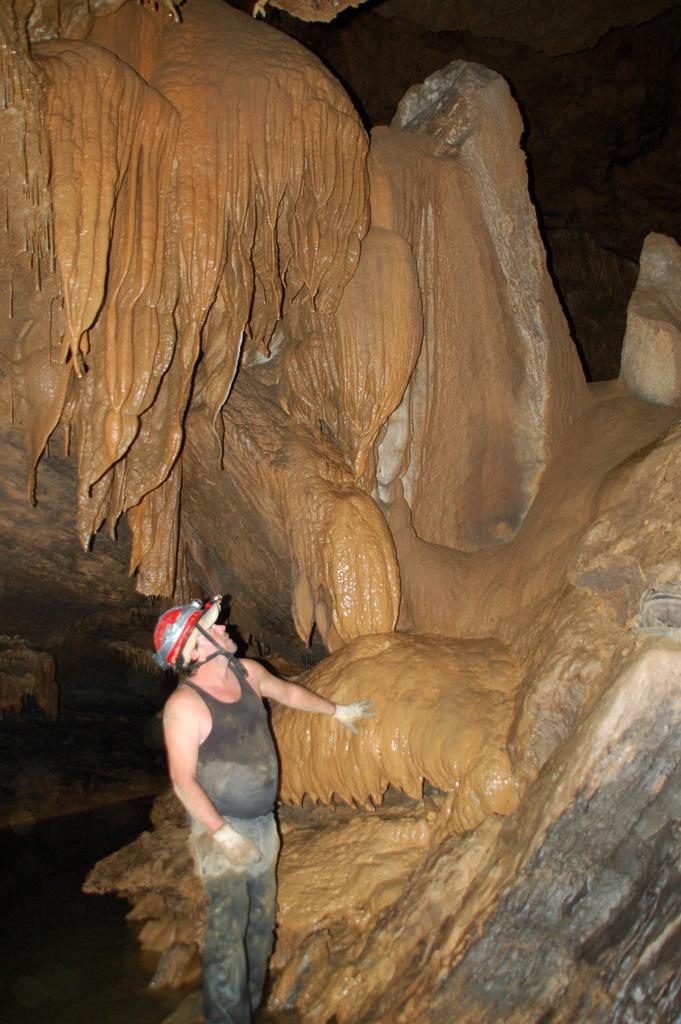Who is present in the image? There is a man in the picture. What is the man doing in the image? The man is standing. What is the man wearing on his head? The man is wearing a helmet. What can be seen in the background of the image? There is something visible in the background of the image. What songs is the kitty playing in the background of the image? There is no kitty or music present in the image. 